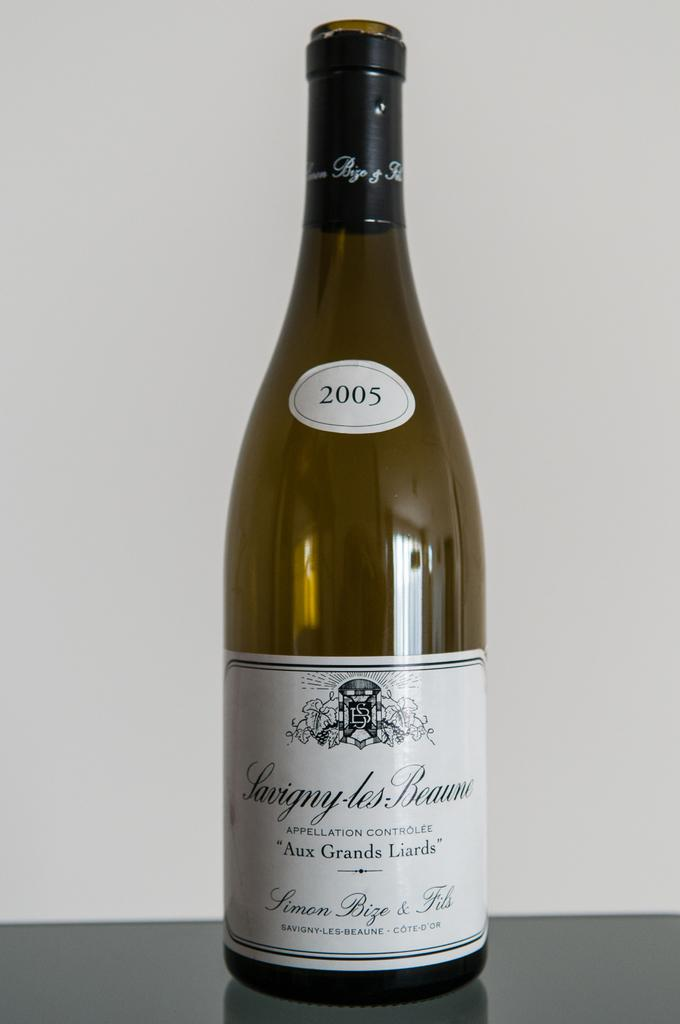<image>
Share a concise interpretation of the image provided. A bottle of wine that has a vintage year of 2005. 